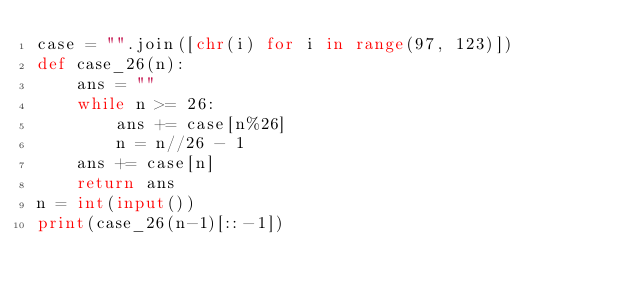<code> <loc_0><loc_0><loc_500><loc_500><_Python_>case = "".join([chr(i) for i in range(97, 123)])
def case_26(n):
    ans = ""
    while n >= 26:
        ans += case[n%26]
        n = n//26 - 1
    ans += case[n]
    return ans
n = int(input())
print(case_26(n-1)[::-1])</code> 